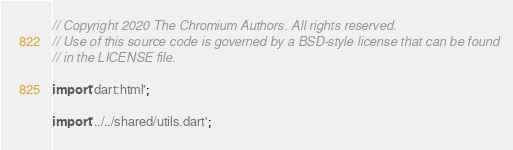Convert code to text. <code><loc_0><loc_0><loc_500><loc_500><_Dart_>// Copyright 2020 The Chromium Authors. All rights reserved.
// Use of this source code is governed by a BSD-style license that can be found
// in the LICENSE file.

import 'dart:html';

import '../../shared/utils.dart';
</code> 